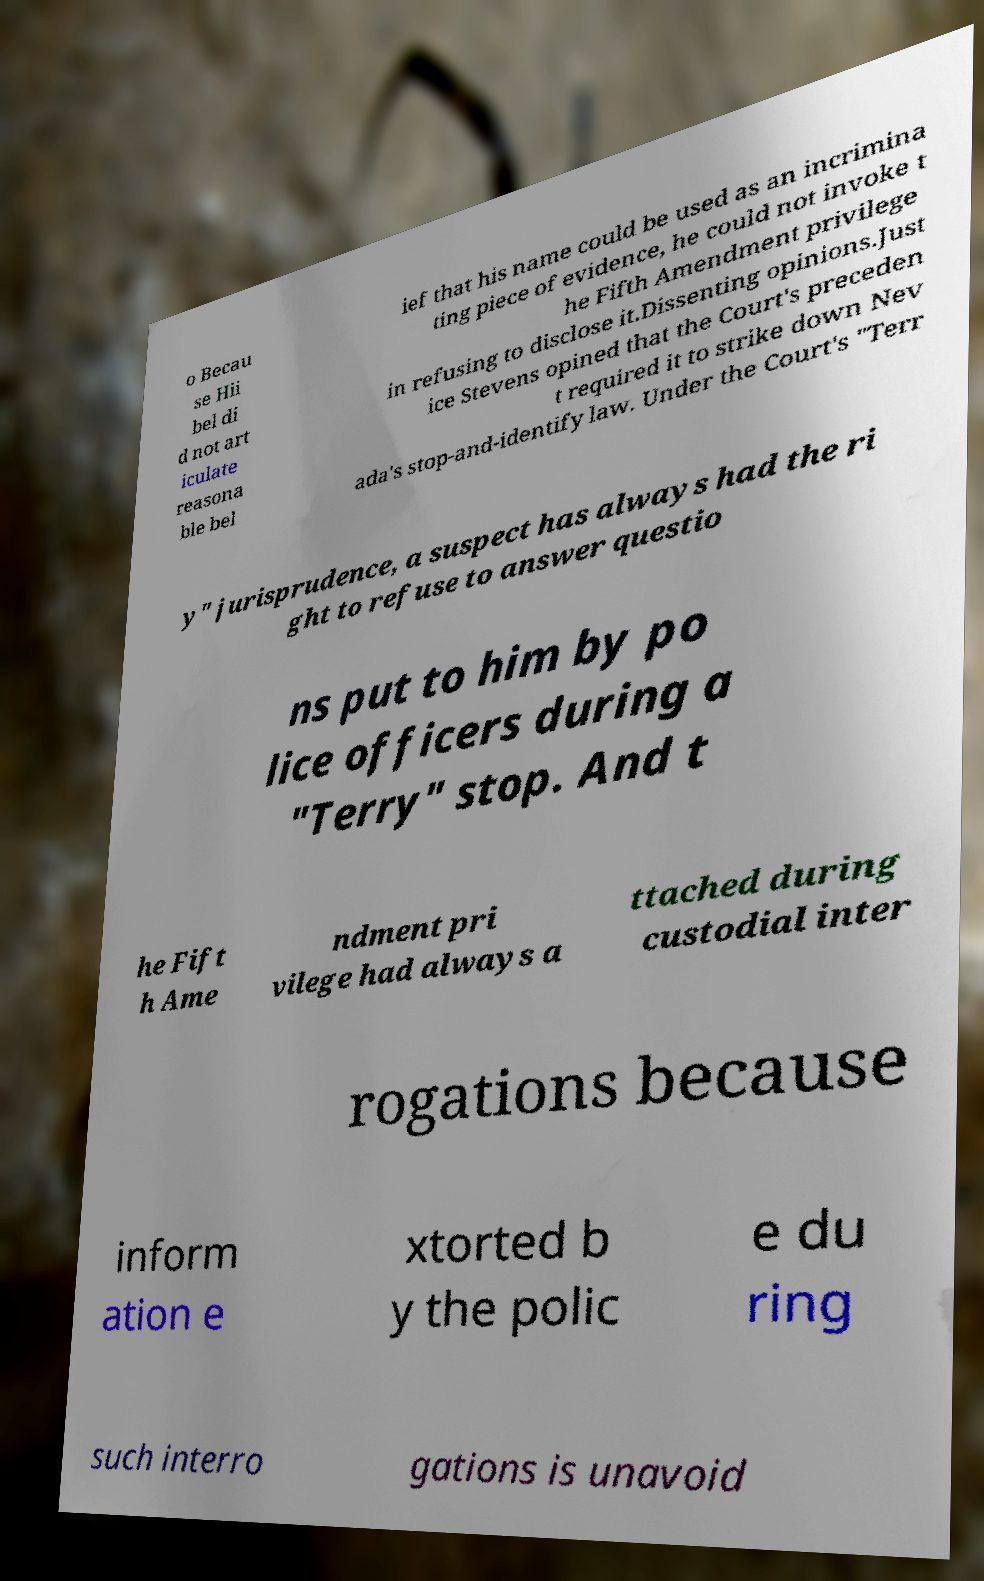I need the written content from this picture converted into text. Can you do that? o Becau se Hii bel di d not art iculate reasona ble bel ief that his name could be used as an incrimina ting piece of evidence, he could not invoke t he Fifth Amendment privilege in refusing to disclose it.Dissenting opinions.Just ice Stevens opined that the Court's preceden t required it to strike down Nev ada's stop-and-identify law. Under the Court's "Terr y" jurisprudence, a suspect has always had the ri ght to refuse to answer questio ns put to him by po lice officers during a "Terry" stop. And t he Fift h Ame ndment pri vilege had always a ttached during custodial inter rogations because inform ation e xtorted b y the polic e du ring such interro gations is unavoid 